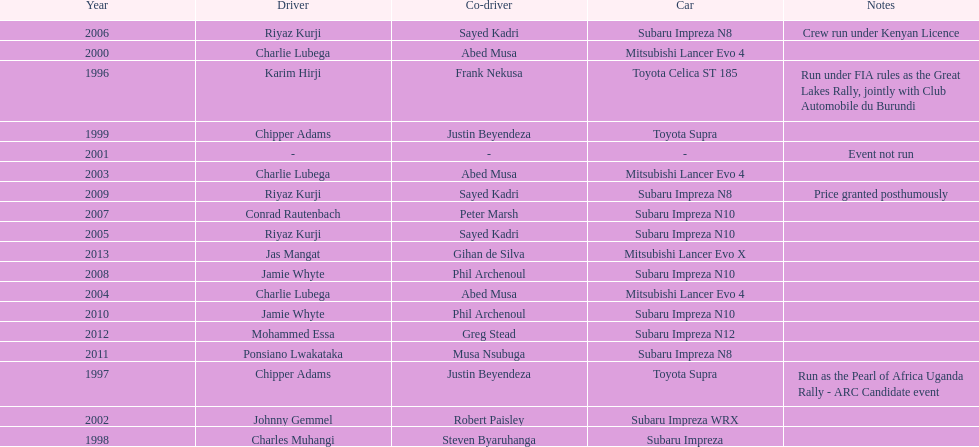Which driver won after ponsiano lwakataka? Mohammed Essa. 